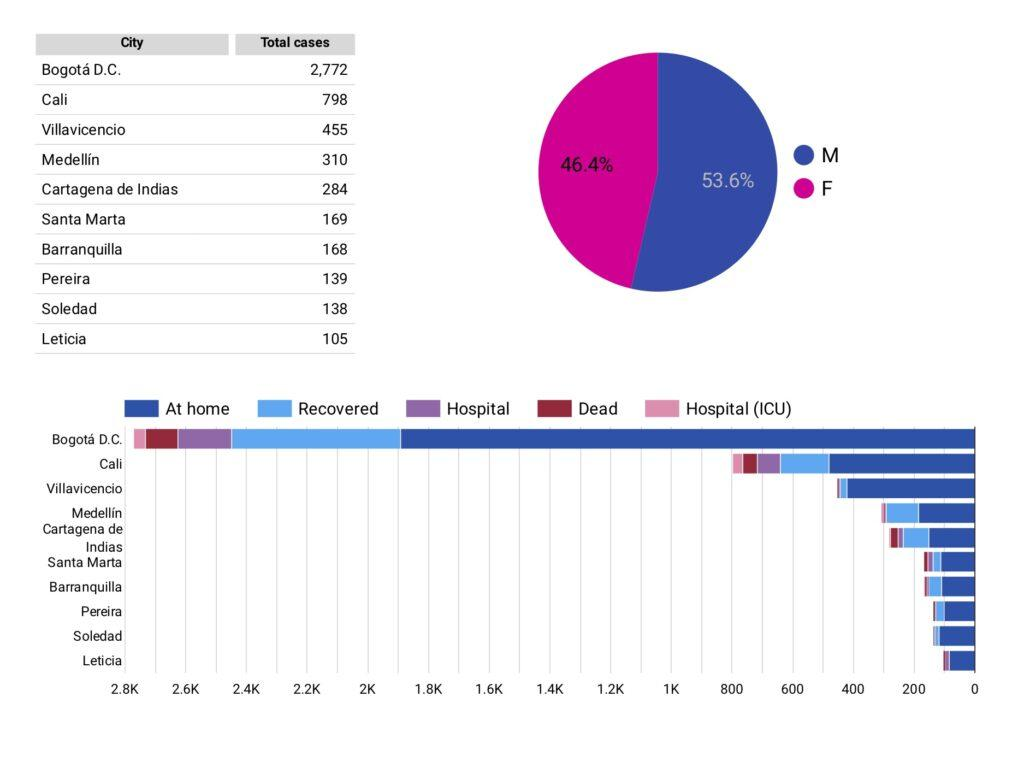Give some essential details in this illustration. In the cases we reviewed, 46.4% of the individuals were female. The color pink is commonly used to represent hospital (ICU) cases. There are regions that have reported a total number of cases between 300 and 500, including Medellin and Villavicencio. The number of total cases in Pereira is higher by 1 than Soledad. The number of total cases in Santa Maria is higher than in Pereira by 30 cases. 